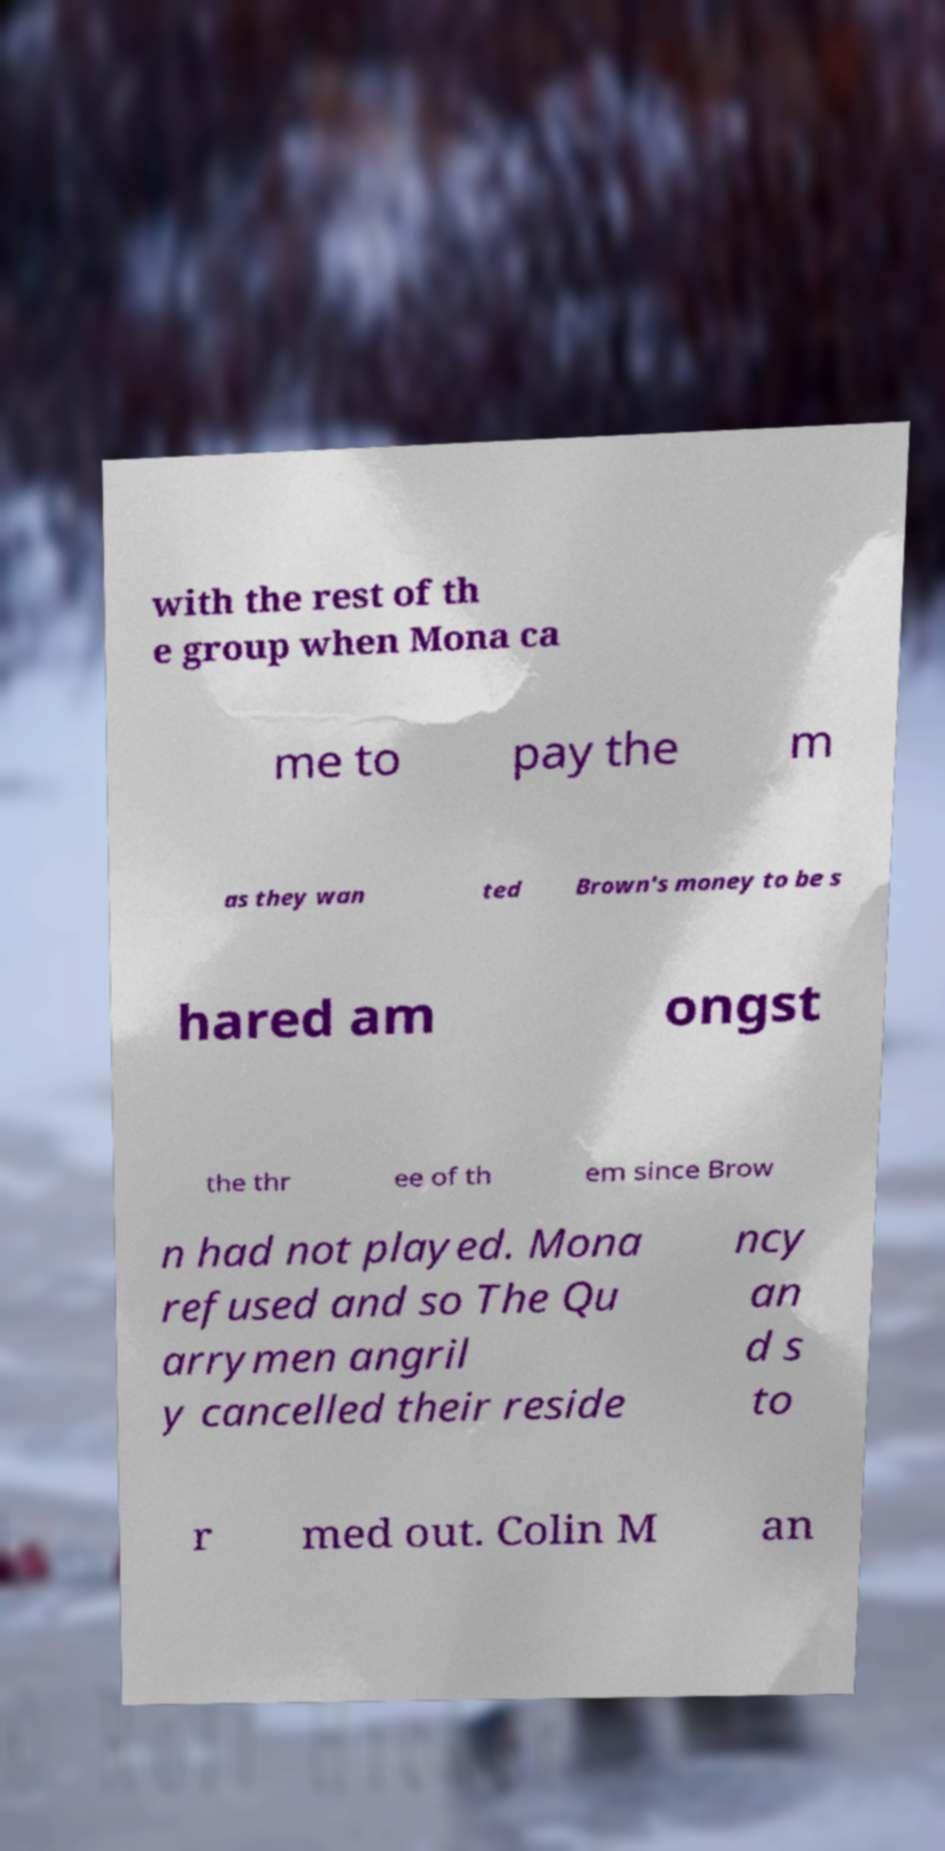I need the written content from this picture converted into text. Can you do that? with the rest of th e group when Mona ca me to pay the m as they wan ted Brown's money to be s hared am ongst the thr ee of th em since Brow n had not played. Mona refused and so The Qu arrymen angril y cancelled their reside ncy an d s to r med out. Colin M an 